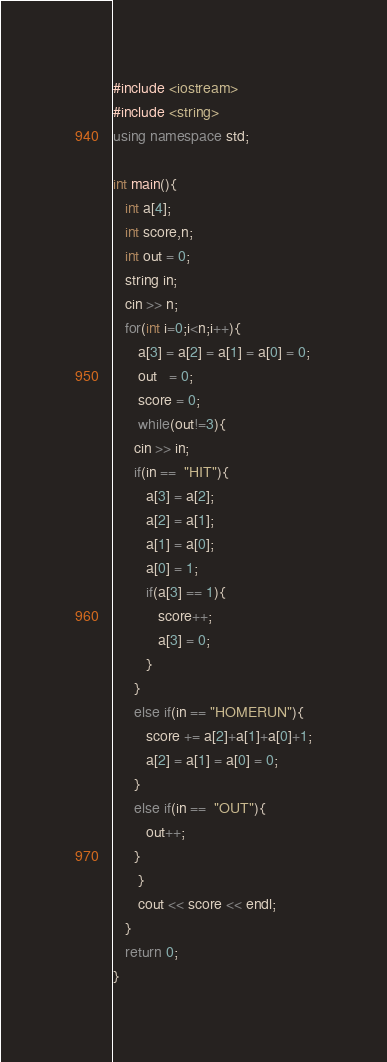Convert code to text. <code><loc_0><loc_0><loc_500><loc_500><_C++_>#include <iostream>
#include <string>
using namespace std;

int main(){
   int a[4];
   int score,n;
   int out = 0;
   string in;
   cin >> n;
   for(int i=0;i<n;i++){
      a[3] = a[2] = a[1] = a[0] = 0;
      out   = 0;
      score = 0;
      while(out!=3){
	 cin >> in;
	 if(in ==  "HIT"){
	    a[3] = a[2];
	    a[2] = a[1];
	    a[1] = a[0];
	    a[0] = 1;
	    if(a[3] == 1){
	       score++;
	       a[3] = 0;
	    }
	 }
	 else if(in == "HOMERUN"){
	    score += a[2]+a[1]+a[0]+1;
	    a[2] = a[1] = a[0] = 0;
	 }
	 else if(in ==  "OUT"){
	    out++;
	 }
      }
      cout << score << endl;
   }
   return 0;
}</code> 